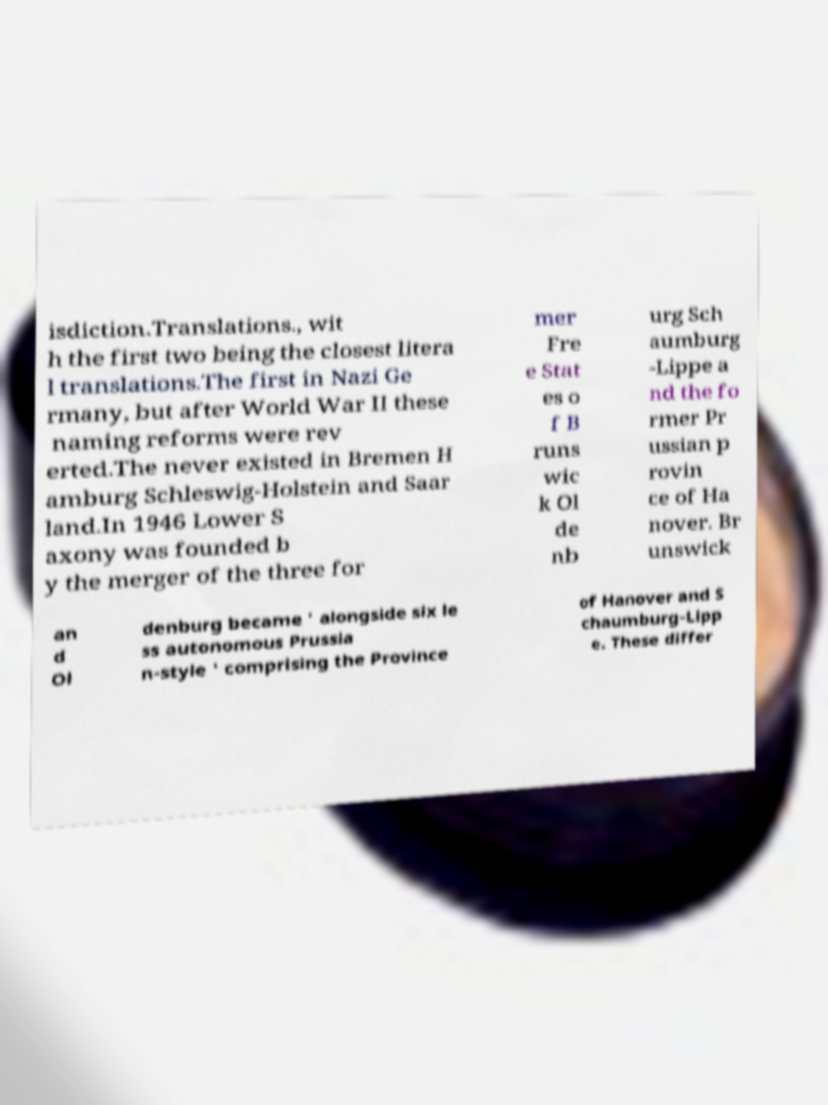Can you read and provide the text displayed in the image?This photo seems to have some interesting text. Can you extract and type it out for me? isdiction.Translations., wit h the first two being the closest litera l translations.The first in Nazi Ge rmany, but after World War II these naming reforms were rev erted.The never existed in Bremen H amburg Schleswig-Holstein and Saar land.In 1946 Lower S axony was founded b y the merger of the three for mer Fre e Stat es o f B runs wic k Ol de nb urg Sch aumburg -Lippe a nd the fo rmer Pr ussian p rovin ce of Ha nover. Br unswick an d Ol denburg became ' alongside six le ss autonomous Prussia n-style ' comprising the Province of Hanover and S chaumburg-Lipp e. These differ 